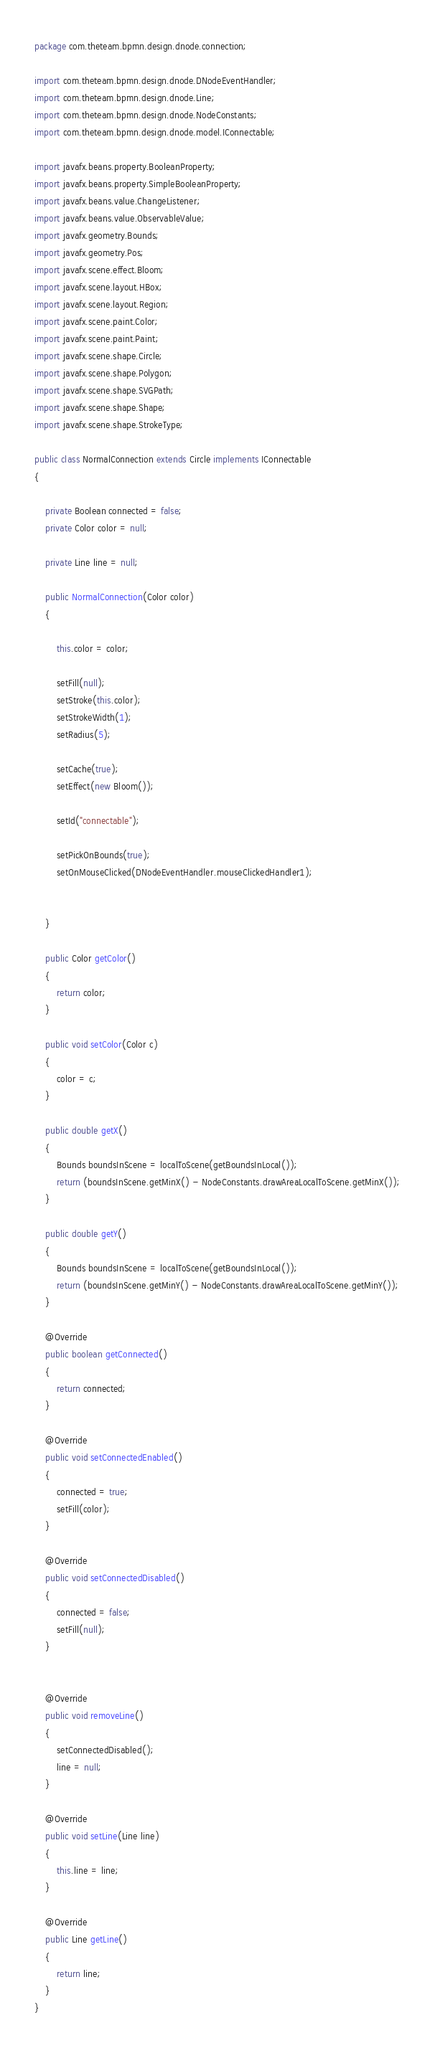Convert code to text. <code><loc_0><loc_0><loc_500><loc_500><_Java_>package com.theteam.bpmn.design.dnode.connection;

import com.theteam.bpmn.design.dnode.DNodeEventHandler;
import com.theteam.bpmn.design.dnode.Line;
import com.theteam.bpmn.design.dnode.NodeConstants;
import com.theteam.bpmn.design.dnode.model.IConnectable;

import javafx.beans.property.BooleanProperty;
import javafx.beans.property.SimpleBooleanProperty;
import javafx.beans.value.ChangeListener;
import javafx.beans.value.ObservableValue;
import javafx.geometry.Bounds;
import javafx.geometry.Pos;
import javafx.scene.effect.Bloom;
import javafx.scene.layout.HBox;
import javafx.scene.layout.Region;
import javafx.scene.paint.Color;
import javafx.scene.paint.Paint;
import javafx.scene.shape.Circle;
import javafx.scene.shape.Polygon;
import javafx.scene.shape.SVGPath;
import javafx.scene.shape.Shape;
import javafx.scene.shape.StrokeType;

public class NormalConnection extends Circle implements IConnectable
{

    private Boolean connected = false;
    private Color color = null;

    private Line line = null;

    public NormalConnection(Color color)
    {
        
        this.color = color;
        
        setFill(null);
        setStroke(this.color);
        setStrokeWidth(1);
        setRadius(5);

        setCache(true);
        setEffect(new Bloom());

        setId("connectable");

        setPickOnBounds(true);
        setOnMouseClicked(DNodeEventHandler.mouseClickedHandler1);

        
    }

    public Color getColor()
    {
        return color;
    }

    public void setColor(Color c)
    {
        color = c;
    }

    public double getX()
    {
        Bounds boundsInScene = localToScene(getBoundsInLocal());
        return (boundsInScene.getMinX() - NodeConstants.drawAreaLocalToScene.getMinX());
    }
    
    public double getY()
    {
        Bounds boundsInScene = localToScene(getBoundsInLocal());
        return (boundsInScene.getMinY() - NodeConstants.drawAreaLocalToScene.getMinY());
    }

    @Override
    public boolean getConnected()
    {
        return connected;
    }

    @Override
    public void setConnectedEnabled()
    {
        connected = true;
        setFill(color);
    }

    @Override
    public void setConnectedDisabled()
    {
        connected = false;
        setFill(null);
    }


    @Override
    public void removeLine()
    {
        setConnectedDisabled();
        line = null;
    }

    @Override
    public void setLine(Line line)
    {
        this.line = line;
    }

    @Override
    public Line getLine()
    {
        return line;
    }
}</code> 